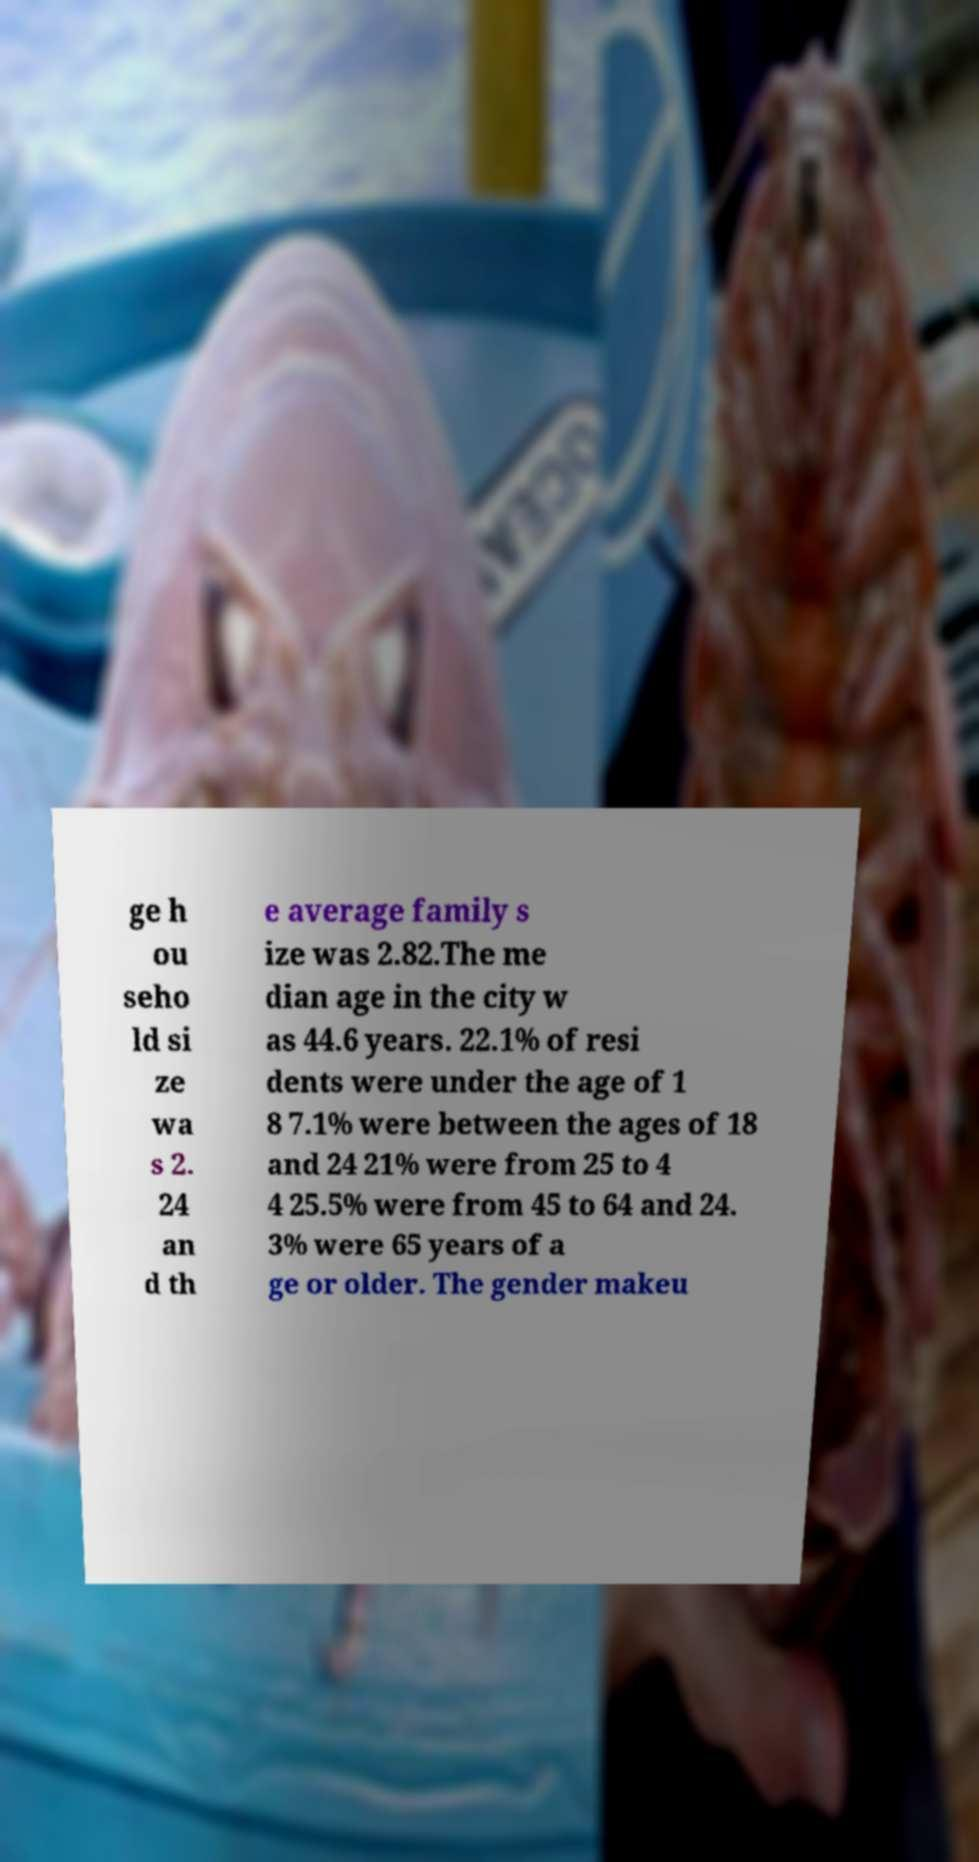For documentation purposes, I need the text within this image transcribed. Could you provide that? ge h ou seho ld si ze wa s 2. 24 an d th e average family s ize was 2.82.The me dian age in the city w as 44.6 years. 22.1% of resi dents were under the age of 1 8 7.1% were between the ages of 18 and 24 21% were from 25 to 4 4 25.5% were from 45 to 64 and 24. 3% were 65 years of a ge or older. The gender makeu 